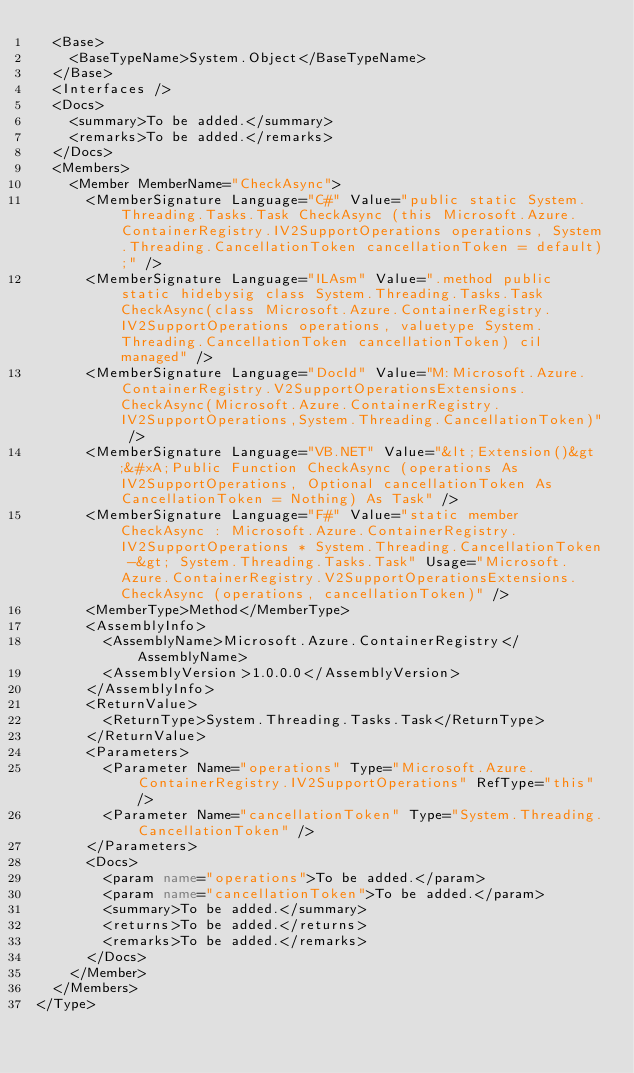<code> <loc_0><loc_0><loc_500><loc_500><_XML_>  <Base>
    <BaseTypeName>System.Object</BaseTypeName>
  </Base>
  <Interfaces />
  <Docs>
    <summary>To be added.</summary>
    <remarks>To be added.</remarks>
  </Docs>
  <Members>
    <Member MemberName="CheckAsync">
      <MemberSignature Language="C#" Value="public static System.Threading.Tasks.Task CheckAsync (this Microsoft.Azure.ContainerRegistry.IV2SupportOperations operations, System.Threading.CancellationToken cancellationToken = default);" />
      <MemberSignature Language="ILAsm" Value=".method public static hidebysig class System.Threading.Tasks.Task CheckAsync(class Microsoft.Azure.ContainerRegistry.IV2SupportOperations operations, valuetype System.Threading.CancellationToken cancellationToken) cil managed" />
      <MemberSignature Language="DocId" Value="M:Microsoft.Azure.ContainerRegistry.V2SupportOperationsExtensions.CheckAsync(Microsoft.Azure.ContainerRegistry.IV2SupportOperations,System.Threading.CancellationToken)" />
      <MemberSignature Language="VB.NET" Value="&lt;Extension()&gt;&#xA;Public Function CheckAsync (operations As IV2SupportOperations, Optional cancellationToken As CancellationToken = Nothing) As Task" />
      <MemberSignature Language="F#" Value="static member CheckAsync : Microsoft.Azure.ContainerRegistry.IV2SupportOperations * System.Threading.CancellationToken -&gt; System.Threading.Tasks.Task" Usage="Microsoft.Azure.ContainerRegistry.V2SupportOperationsExtensions.CheckAsync (operations, cancellationToken)" />
      <MemberType>Method</MemberType>
      <AssemblyInfo>
        <AssemblyName>Microsoft.Azure.ContainerRegistry</AssemblyName>
        <AssemblyVersion>1.0.0.0</AssemblyVersion>
      </AssemblyInfo>
      <ReturnValue>
        <ReturnType>System.Threading.Tasks.Task</ReturnType>
      </ReturnValue>
      <Parameters>
        <Parameter Name="operations" Type="Microsoft.Azure.ContainerRegistry.IV2SupportOperations" RefType="this" />
        <Parameter Name="cancellationToken" Type="System.Threading.CancellationToken" />
      </Parameters>
      <Docs>
        <param name="operations">To be added.</param>
        <param name="cancellationToken">To be added.</param>
        <summary>To be added.</summary>
        <returns>To be added.</returns>
        <remarks>To be added.</remarks>
      </Docs>
    </Member>
  </Members>
</Type>
</code> 